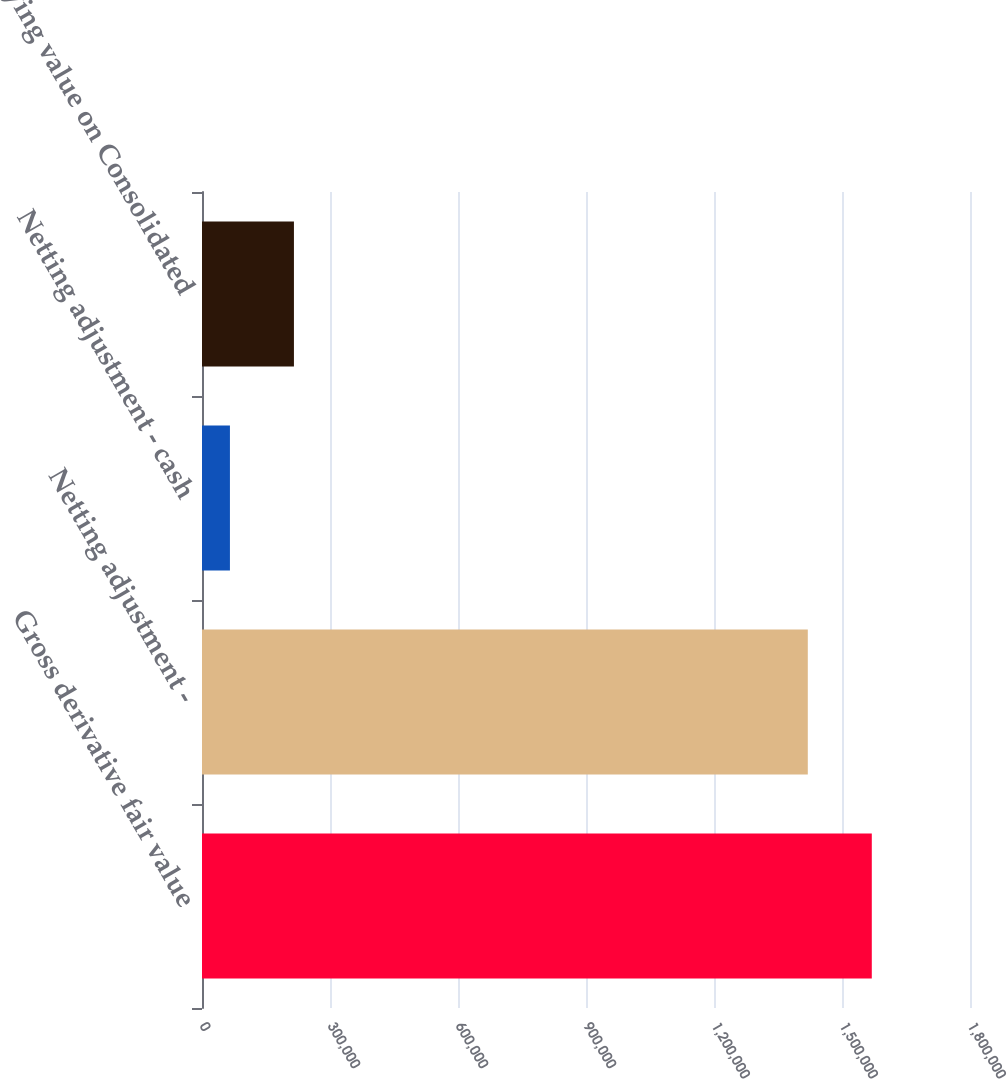Convert chart. <chart><loc_0><loc_0><loc_500><loc_500><bar_chart><fcel>Gross derivative fair value<fcel>Netting adjustment -<fcel>Netting adjustment - cash<fcel>Carrying value on Consolidated<nl><fcel>1.56984e+06<fcel>1.41984e+06<fcel>65468<fcel>215473<nl></chart> 